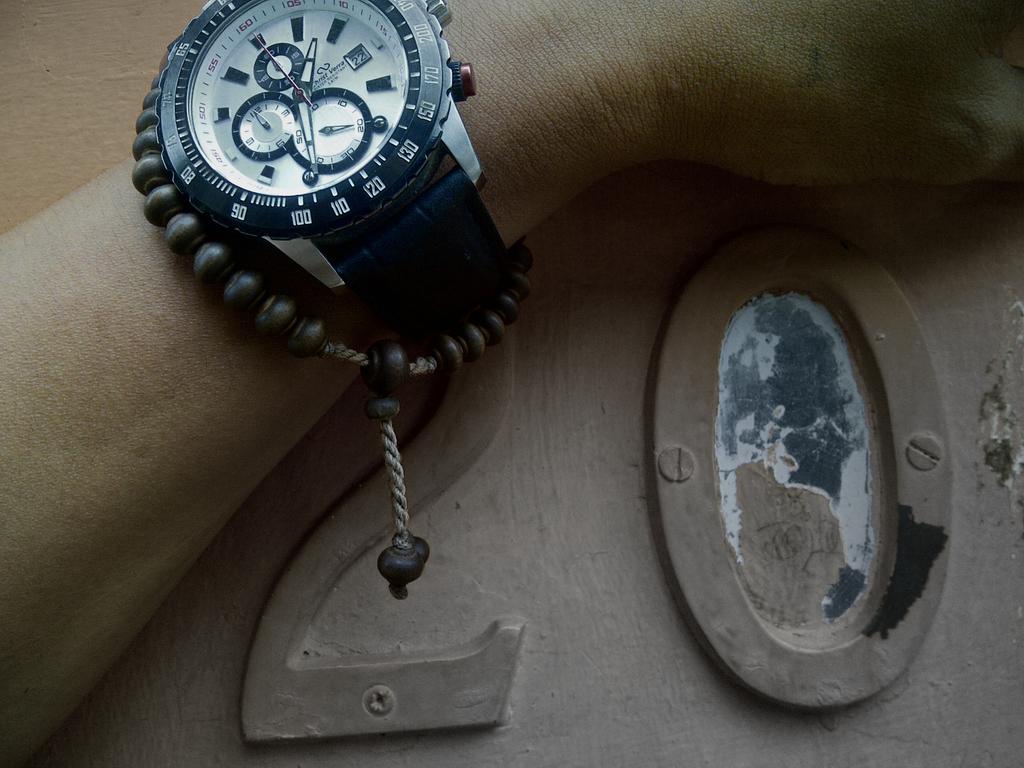What time is diplayed on the watch?
Provide a short and direct response. 1:35. Does the little box say 22?
Provide a short and direct response. No. 